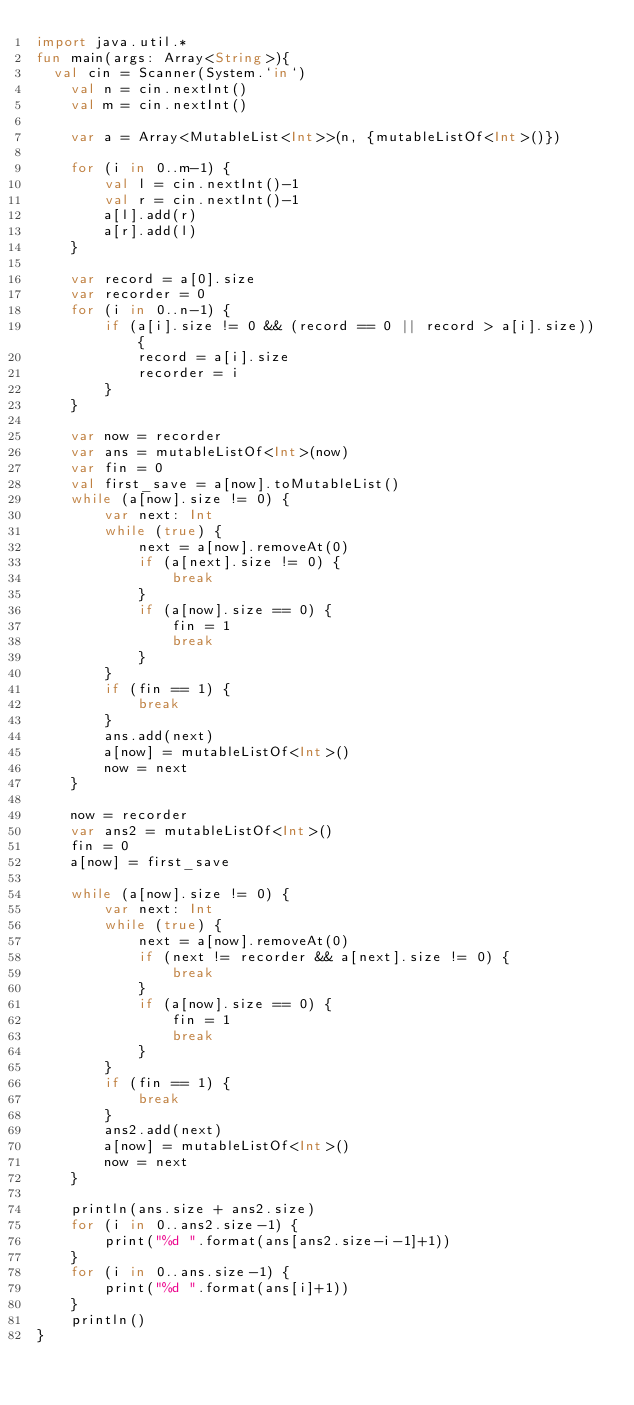Convert code to text. <code><loc_0><loc_0><loc_500><loc_500><_Kotlin_>import java.util.*
fun main(args: Array<String>){
	val cin = Scanner(System.`in`)
    val n = cin.nextInt()
    val m = cin.nextInt()

    var a = Array<MutableList<Int>>(n, {mutableListOf<Int>()})

    for (i in 0..m-1) {
        val l = cin.nextInt()-1
        val r = cin.nextInt()-1
        a[l].add(r)
        a[r].add(l)
    }

    var record = a[0].size
    var recorder = 0
    for (i in 0..n-1) {
        if (a[i].size != 0 && (record == 0 || record > a[i].size)) {
            record = a[i].size
            recorder = i
        }
    }

    var now = recorder
    var ans = mutableListOf<Int>(now)
    var fin = 0
    val first_save = a[now].toMutableList()
    while (a[now].size != 0) {
        var next: Int
        while (true) {
            next = a[now].removeAt(0)
            if (a[next].size != 0) {
                break
            }
            if (a[now].size == 0) {
                fin = 1
                break
            }
        }
        if (fin == 1) {
            break
        }
        ans.add(next)
        a[now] = mutableListOf<Int>()
        now = next
    }
    
    now = recorder
    var ans2 = mutableListOf<Int>()
    fin = 0
    a[now] = first_save

    while (a[now].size != 0) {
        var next: Int
        while (true) {
            next = a[now].removeAt(0)
            if (next != recorder && a[next].size != 0) {
                break
            }
            if (a[now].size == 0) {
                fin = 1
                break
            }
        }
        if (fin == 1) {
            break
        }
        ans2.add(next)
        a[now] = mutableListOf<Int>()
        now = next
    }

    println(ans.size + ans2.size)
    for (i in 0..ans2.size-1) {
        print("%d ".format(ans[ans2.size-i-1]+1))
    }
    for (i in 0..ans.size-1) {
        print("%d ".format(ans[i]+1))
    }
    println()
}</code> 